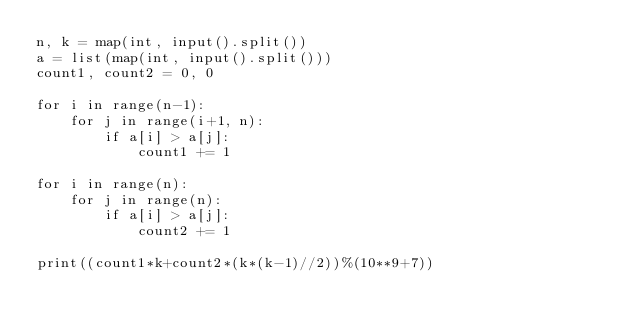<code> <loc_0><loc_0><loc_500><loc_500><_Python_>n, k = map(int, input().split())
a = list(map(int, input().split()))
count1, count2 = 0, 0

for i in range(n-1):
    for j in range(i+1, n):
        if a[i] > a[j]:
            count1 += 1

for i in range(n):
    for j in range(n):
        if a[i] > a[j]:
            count2 += 1
            
print((count1*k+count2*(k*(k-1)//2))%(10**9+7))
        
</code> 